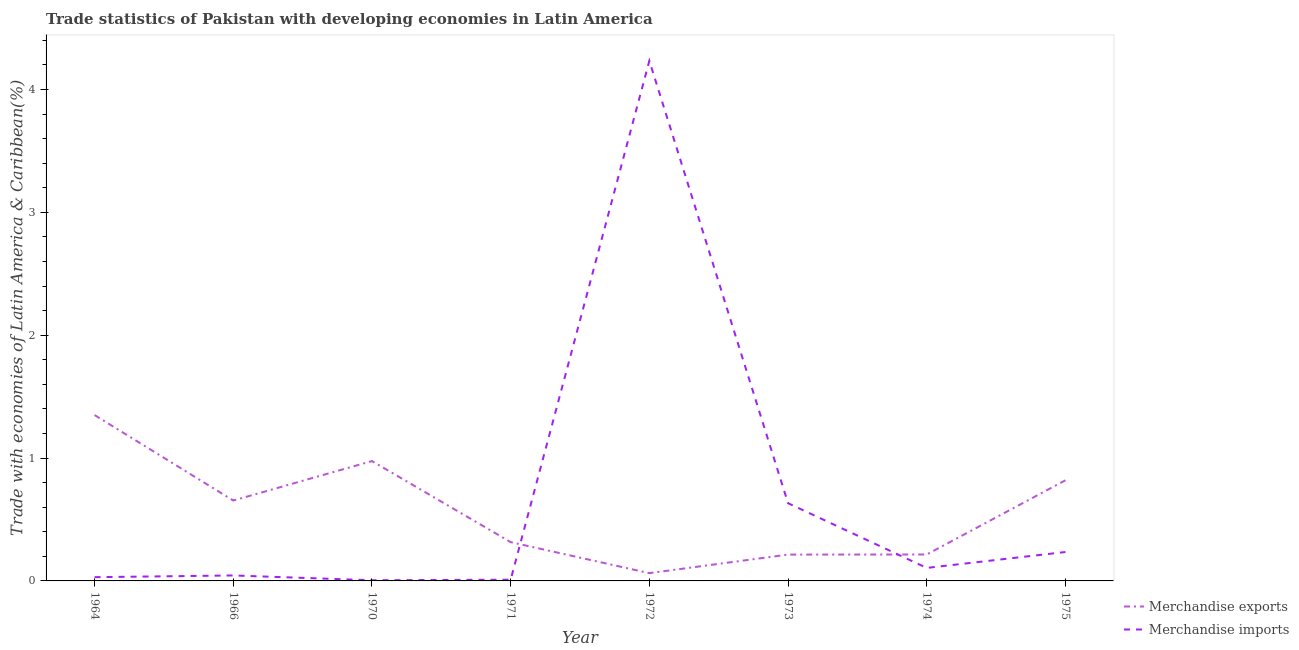What is the merchandise exports in 1972?
Provide a short and direct response. 0.06. Across all years, what is the maximum merchandise imports?
Provide a succinct answer. 4.23. Across all years, what is the minimum merchandise exports?
Keep it short and to the point. 0.06. In which year was the merchandise exports maximum?
Offer a very short reply. 1964. What is the total merchandise imports in the graph?
Your response must be concise. 5.3. What is the difference between the merchandise imports in 1972 and that in 1974?
Provide a short and direct response. 4.13. What is the difference between the merchandise exports in 1974 and the merchandise imports in 1971?
Give a very brief answer. 0.21. What is the average merchandise imports per year?
Provide a succinct answer. 0.66. In the year 1966, what is the difference between the merchandise imports and merchandise exports?
Make the answer very short. -0.61. In how many years, is the merchandise imports greater than 3 %?
Provide a short and direct response. 1. What is the ratio of the merchandise imports in 1973 to that in 1974?
Provide a short and direct response. 5.98. Is the merchandise exports in 1964 less than that in 1970?
Provide a short and direct response. No. What is the difference between the highest and the second highest merchandise exports?
Make the answer very short. 0.37. What is the difference between the highest and the lowest merchandise exports?
Ensure brevity in your answer.  1.29. In how many years, is the merchandise exports greater than the average merchandise exports taken over all years?
Your response must be concise. 4. Is the sum of the merchandise exports in 1964 and 1973 greater than the maximum merchandise imports across all years?
Your answer should be very brief. No. How many lines are there?
Ensure brevity in your answer.  2. What is the difference between two consecutive major ticks on the Y-axis?
Provide a short and direct response. 1. Does the graph contain grids?
Your answer should be very brief. No. How many legend labels are there?
Offer a very short reply. 2. How are the legend labels stacked?
Offer a very short reply. Vertical. What is the title of the graph?
Give a very brief answer. Trade statistics of Pakistan with developing economies in Latin America. Does "Male entrants" appear as one of the legend labels in the graph?
Provide a succinct answer. No. What is the label or title of the X-axis?
Offer a terse response. Year. What is the label or title of the Y-axis?
Provide a short and direct response. Trade with economies of Latin America & Caribbean(%). What is the Trade with economies of Latin America & Caribbean(%) of Merchandise exports in 1964?
Keep it short and to the point. 1.35. What is the Trade with economies of Latin America & Caribbean(%) in Merchandise imports in 1964?
Ensure brevity in your answer.  0.03. What is the Trade with economies of Latin America & Caribbean(%) in Merchandise exports in 1966?
Make the answer very short. 0.65. What is the Trade with economies of Latin America & Caribbean(%) of Merchandise imports in 1966?
Offer a very short reply. 0.04. What is the Trade with economies of Latin America & Caribbean(%) of Merchandise exports in 1970?
Offer a terse response. 0.98. What is the Trade with economies of Latin America & Caribbean(%) in Merchandise imports in 1970?
Provide a short and direct response. 0.01. What is the Trade with economies of Latin America & Caribbean(%) in Merchandise exports in 1971?
Offer a very short reply. 0.32. What is the Trade with economies of Latin America & Caribbean(%) in Merchandise imports in 1971?
Give a very brief answer. 0.01. What is the Trade with economies of Latin America & Caribbean(%) in Merchandise exports in 1972?
Ensure brevity in your answer.  0.06. What is the Trade with economies of Latin America & Caribbean(%) of Merchandise imports in 1972?
Offer a very short reply. 4.23. What is the Trade with economies of Latin America & Caribbean(%) in Merchandise exports in 1973?
Offer a very short reply. 0.21. What is the Trade with economies of Latin America & Caribbean(%) of Merchandise imports in 1973?
Your answer should be very brief. 0.63. What is the Trade with economies of Latin America & Caribbean(%) of Merchandise exports in 1974?
Provide a succinct answer. 0.22. What is the Trade with economies of Latin America & Caribbean(%) of Merchandise imports in 1974?
Your answer should be very brief. 0.11. What is the Trade with economies of Latin America & Caribbean(%) of Merchandise exports in 1975?
Your response must be concise. 0.82. What is the Trade with economies of Latin America & Caribbean(%) in Merchandise imports in 1975?
Your answer should be very brief. 0.24. Across all years, what is the maximum Trade with economies of Latin America & Caribbean(%) of Merchandise exports?
Your answer should be very brief. 1.35. Across all years, what is the maximum Trade with economies of Latin America & Caribbean(%) in Merchandise imports?
Provide a succinct answer. 4.23. Across all years, what is the minimum Trade with economies of Latin America & Caribbean(%) in Merchandise exports?
Keep it short and to the point. 0.06. Across all years, what is the minimum Trade with economies of Latin America & Caribbean(%) of Merchandise imports?
Ensure brevity in your answer.  0.01. What is the total Trade with economies of Latin America & Caribbean(%) in Merchandise exports in the graph?
Make the answer very short. 4.61. What is the total Trade with economies of Latin America & Caribbean(%) in Merchandise imports in the graph?
Keep it short and to the point. 5.3. What is the difference between the Trade with economies of Latin America & Caribbean(%) in Merchandise exports in 1964 and that in 1966?
Your answer should be compact. 0.7. What is the difference between the Trade with economies of Latin America & Caribbean(%) of Merchandise imports in 1964 and that in 1966?
Offer a terse response. -0.01. What is the difference between the Trade with economies of Latin America & Caribbean(%) in Merchandise exports in 1964 and that in 1970?
Your response must be concise. 0.37. What is the difference between the Trade with economies of Latin America & Caribbean(%) in Merchandise imports in 1964 and that in 1970?
Make the answer very short. 0.03. What is the difference between the Trade with economies of Latin America & Caribbean(%) in Merchandise exports in 1964 and that in 1971?
Your answer should be compact. 1.03. What is the difference between the Trade with economies of Latin America & Caribbean(%) of Merchandise imports in 1964 and that in 1971?
Provide a short and direct response. 0.02. What is the difference between the Trade with economies of Latin America & Caribbean(%) of Merchandise exports in 1964 and that in 1972?
Your answer should be very brief. 1.29. What is the difference between the Trade with economies of Latin America & Caribbean(%) of Merchandise imports in 1964 and that in 1972?
Make the answer very short. -4.2. What is the difference between the Trade with economies of Latin America & Caribbean(%) of Merchandise exports in 1964 and that in 1973?
Give a very brief answer. 1.14. What is the difference between the Trade with economies of Latin America & Caribbean(%) in Merchandise imports in 1964 and that in 1973?
Offer a very short reply. -0.6. What is the difference between the Trade with economies of Latin America & Caribbean(%) in Merchandise exports in 1964 and that in 1974?
Your answer should be very brief. 1.13. What is the difference between the Trade with economies of Latin America & Caribbean(%) of Merchandise imports in 1964 and that in 1974?
Ensure brevity in your answer.  -0.08. What is the difference between the Trade with economies of Latin America & Caribbean(%) in Merchandise exports in 1964 and that in 1975?
Your answer should be very brief. 0.53. What is the difference between the Trade with economies of Latin America & Caribbean(%) of Merchandise imports in 1964 and that in 1975?
Your answer should be compact. -0.2. What is the difference between the Trade with economies of Latin America & Caribbean(%) of Merchandise exports in 1966 and that in 1970?
Offer a terse response. -0.32. What is the difference between the Trade with economies of Latin America & Caribbean(%) in Merchandise imports in 1966 and that in 1970?
Offer a terse response. 0.04. What is the difference between the Trade with economies of Latin America & Caribbean(%) of Merchandise exports in 1966 and that in 1971?
Your response must be concise. 0.34. What is the difference between the Trade with economies of Latin America & Caribbean(%) of Merchandise imports in 1966 and that in 1971?
Give a very brief answer. 0.03. What is the difference between the Trade with economies of Latin America & Caribbean(%) of Merchandise exports in 1966 and that in 1972?
Your response must be concise. 0.59. What is the difference between the Trade with economies of Latin America & Caribbean(%) of Merchandise imports in 1966 and that in 1972?
Your answer should be compact. -4.19. What is the difference between the Trade with economies of Latin America & Caribbean(%) in Merchandise exports in 1966 and that in 1973?
Your response must be concise. 0.44. What is the difference between the Trade with economies of Latin America & Caribbean(%) in Merchandise imports in 1966 and that in 1973?
Your response must be concise. -0.59. What is the difference between the Trade with economies of Latin America & Caribbean(%) in Merchandise exports in 1966 and that in 1974?
Your response must be concise. 0.44. What is the difference between the Trade with economies of Latin America & Caribbean(%) in Merchandise imports in 1966 and that in 1974?
Your answer should be very brief. -0.06. What is the difference between the Trade with economies of Latin America & Caribbean(%) in Merchandise exports in 1966 and that in 1975?
Your response must be concise. -0.16. What is the difference between the Trade with economies of Latin America & Caribbean(%) of Merchandise imports in 1966 and that in 1975?
Your answer should be very brief. -0.19. What is the difference between the Trade with economies of Latin America & Caribbean(%) of Merchandise exports in 1970 and that in 1971?
Offer a terse response. 0.66. What is the difference between the Trade with economies of Latin America & Caribbean(%) of Merchandise imports in 1970 and that in 1971?
Offer a terse response. -0. What is the difference between the Trade with economies of Latin America & Caribbean(%) of Merchandise exports in 1970 and that in 1972?
Your response must be concise. 0.91. What is the difference between the Trade with economies of Latin America & Caribbean(%) of Merchandise imports in 1970 and that in 1972?
Provide a succinct answer. -4.23. What is the difference between the Trade with economies of Latin America & Caribbean(%) of Merchandise exports in 1970 and that in 1973?
Offer a terse response. 0.76. What is the difference between the Trade with economies of Latin America & Caribbean(%) in Merchandise imports in 1970 and that in 1973?
Offer a terse response. -0.63. What is the difference between the Trade with economies of Latin America & Caribbean(%) in Merchandise exports in 1970 and that in 1974?
Provide a short and direct response. 0.76. What is the difference between the Trade with economies of Latin America & Caribbean(%) in Merchandise imports in 1970 and that in 1974?
Your response must be concise. -0.1. What is the difference between the Trade with economies of Latin America & Caribbean(%) of Merchandise exports in 1970 and that in 1975?
Make the answer very short. 0.16. What is the difference between the Trade with economies of Latin America & Caribbean(%) of Merchandise imports in 1970 and that in 1975?
Your answer should be very brief. -0.23. What is the difference between the Trade with economies of Latin America & Caribbean(%) in Merchandise exports in 1971 and that in 1972?
Offer a terse response. 0.25. What is the difference between the Trade with economies of Latin America & Caribbean(%) of Merchandise imports in 1971 and that in 1972?
Give a very brief answer. -4.22. What is the difference between the Trade with economies of Latin America & Caribbean(%) of Merchandise exports in 1971 and that in 1973?
Your answer should be compact. 0.1. What is the difference between the Trade with economies of Latin America & Caribbean(%) in Merchandise imports in 1971 and that in 1973?
Your answer should be very brief. -0.62. What is the difference between the Trade with economies of Latin America & Caribbean(%) in Merchandise exports in 1971 and that in 1974?
Keep it short and to the point. 0.1. What is the difference between the Trade with economies of Latin America & Caribbean(%) in Merchandise imports in 1971 and that in 1974?
Provide a succinct answer. -0.1. What is the difference between the Trade with economies of Latin America & Caribbean(%) of Merchandise exports in 1971 and that in 1975?
Your response must be concise. -0.5. What is the difference between the Trade with economies of Latin America & Caribbean(%) in Merchandise imports in 1971 and that in 1975?
Your answer should be very brief. -0.23. What is the difference between the Trade with economies of Latin America & Caribbean(%) of Merchandise exports in 1972 and that in 1973?
Your answer should be very brief. -0.15. What is the difference between the Trade with economies of Latin America & Caribbean(%) of Merchandise imports in 1972 and that in 1973?
Make the answer very short. 3.6. What is the difference between the Trade with economies of Latin America & Caribbean(%) in Merchandise exports in 1972 and that in 1974?
Offer a terse response. -0.15. What is the difference between the Trade with economies of Latin America & Caribbean(%) in Merchandise imports in 1972 and that in 1974?
Provide a short and direct response. 4.13. What is the difference between the Trade with economies of Latin America & Caribbean(%) in Merchandise exports in 1972 and that in 1975?
Keep it short and to the point. -0.76. What is the difference between the Trade with economies of Latin America & Caribbean(%) of Merchandise imports in 1972 and that in 1975?
Your answer should be compact. 4. What is the difference between the Trade with economies of Latin America & Caribbean(%) in Merchandise exports in 1973 and that in 1974?
Give a very brief answer. -0. What is the difference between the Trade with economies of Latin America & Caribbean(%) of Merchandise imports in 1973 and that in 1974?
Your response must be concise. 0.53. What is the difference between the Trade with economies of Latin America & Caribbean(%) of Merchandise exports in 1973 and that in 1975?
Keep it short and to the point. -0.6. What is the difference between the Trade with economies of Latin America & Caribbean(%) of Merchandise imports in 1973 and that in 1975?
Provide a short and direct response. 0.4. What is the difference between the Trade with economies of Latin America & Caribbean(%) of Merchandise exports in 1974 and that in 1975?
Provide a succinct answer. -0.6. What is the difference between the Trade with economies of Latin America & Caribbean(%) of Merchandise imports in 1974 and that in 1975?
Your answer should be very brief. -0.13. What is the difference between the Trade with economies of Latin America & Caribbean(%) in Merchandise exports in 1964 and the Trade with economies of Latin America & Caribbean(%) in Merchandise imports in 1966?
Your response must be concise. 1.31. What is the difference between the Trade with economies of Latin America & Caribbean(%) in Merchandise exports in 1964 and the Trade with economies of Latin America & Caribbean(%) in Merchandise imports in 1970?
Give a very brief answer. 1.34. What is the difference between the Trade with economies of Latin America & Caribbean(%) in Merchandise exports in 1964 and the Trade with economies of Latin America & Caribbean(%) in Merchandise imports in 1971?
Offer a terse response. 1.34. What is the difference between the Trade with economies of Latin America & Caribbean(%) in Merchandise exports in 1964 and the Trade with economies of Latin America & Caribbean(%) in Merchandise imports in 1972?
Provide a succinct answer. -2.88. What is the difference between the Trade with economies of Latin America & Caribbean(%) in Merchandise exports in 1964 and the Trade with economies of Latin America & Caribbean(%) in Merchandise imports in 1973?
Make the answer very short. 0.72. What is the difference between the Trade with economies of Latin America & Caribbean(%) of Merchandise exports in 1964 and the Trade with economies of Latin America & Caribbean(%) of Merchandise imports in 1974?
Your response must be concise. 1.24. What is the difference between the Trade with economies of Latin America & Caribbean(%) of Merchandise exports in 1964 and the Trade with economies of Latin America & Caribbean(%) of Merchandise imports in 1975?
Offer a terse response. 1.11. What is the difference between the Trade with economies of Latin America & Caribbean(%) of Merchandise exports in 1966 and the Trade with economies of Latin America & Caribbean(%) of Merchandise imports in 1970?
Your response must be concise. 0.65. What is the difference between the Trade with economies of Latin America & Caribbean(%) of Merchandise exports in 1966 and the Trade with economies of Latin America & Caribbean(%) of Merchandise imports in 1971?
Your answer should be compact. 0.64. What is the difference between the Trade with economies of Latin America & Caribbean(%) in Merchandise exports in 1966 and the Trade with economies of Latin America & Caribbean(%) in Merchandise imports in 1972?
Make the answer very short. -3.58. What is the difference between the Trade with economies of Latin America & Caribbean(%) of Merchandise exports in 1966 and the Trade with economies of Latin America & Caribbean(%) of Merchandise imports in 1973?
Your response must be concise. 0.02. What is the difference between the Trade with economies of Latin America & Caribbean(%) of Merchandise exports in 1966 and the Trade with economies of Latin America & Caribbean(%) of Merchandise imports in 1974?
Ensure brevity in your answer.  0.55. What is the difference between the Trade with economies of Latin America & Caribbean(%) of Merchandise exports in 1966 and the Trade with economies of Latin America & Caribbean(%) of Merchandise imports in 1975?
Offer a terse response. 0.42. What is the difference between the Trade with economies of Latin America & Caribbean(%) of Merchandise exports in 1970 and the Trade with economies of Latin America & Caribbean(%) of Merchandise imports in 1971?
Ensure brevity in your answer.  0.97. What is the difference between the Trade with economies of Latin America & Caribbean(%) of Merchandise exports in 1970 and the Trade with economies of Latin America & Caribbean(%) of Merchandise imports in 1972?
Your answer should be compact. -3.26. What is the difference between the Trade with economies of Latin America & Caribbean(%) in Merchandise exports in 1970 and the Trade with economies of Latin America & Caribbean(%) in Merchandise imports in 1973?
Ensure brevity in your answer.  0.34. What is the difference between the Trade with economies of Latin America & Caribbean(%) in Merchandise exports in 1970 and the Trade with economies of Latin America & Caribbean(%) in Merchandise imports in 1974?
Offer a very short reply. 0.87. What is the difference between the Trade with economies of Latin America & Caribbean(%) in Merchandise exports in 1970 and the Trade with economies of Latin America & Caribbean(%) in Merchandise imports in 1975?
Make the answer very short. 0.74. What is the difference between the Trade with economies of Latin America & Caribbean(%) of Merchandise exports in 1971 and the Trade with economies of Latin America & Caribbean(%) of Merchandise imports in 1972?
Your response must be concise. -3.92. What is the difference between the Trade with economies of Latin America & Caribbean(%) in Merchandise exports in 1971 and the Trade with economies of Latin America & Caribbean(%) in Merchandise imports in 1973?
Offer a terse response. -0.32. What is the difference between the Trade with economies of Latin America & Caribbean(%) of Merchandise exports in 1971 and the Trade with economies of Latin America & Caribbean(%) of Merchandise imports in 1974?
Provide a succinct answer. 0.21. What is the difference between the Trade with economies of Latin America & Caribbean(%) in Merchandise exports in 1971 and the Trade with economies of Latin America & Caribbean(%) in Merchandise imports in 1975?
Your answer should be compact. 0.08. What is the difference between the Trade with economies of Latin America & Caribbean(%) in Merchandise exports in 1972 and the Trade with economies of Latin America & Caribbean(%) in Merchandise imports in 1973?
Your answer should be compact. -0.57. What is the difference between the Trade with economies of Latin America & Caribbean(%) of Merchandise exports in 1972 and the Trade with economies of Latin America & Caribbean(%) of Merchandise imports in 1974?
Ensure brevity in your answer.  -0.04. What is the difference between the Trade with economies of Latin America & Caribbean(%) of Merchandise exports in 1972 and the Trade with economies of Latin America & Caribbean(%) of Merchandise imports in 1975?
Make the answer very short. -0.17. What is the difference between the Trade with economies of Latin America & Caribbean(%) of Merchandise exports in 1973 and the Trade with economies of Latin America & Caribbean(%) of Merchandise imports in 1974?
Keep it short and to the point. 0.11. What is the difference between the Trade with economies of Latin America & Caribbean(%) in Merchandise exports in 1973 and the Trade with economies of Latin America & Caribbean(%) in Merchandise imports in 1975?
Make the answer very short. -0.02. What is the difference between the Trade with economies of Latin America & Caribbean(%) of Merchandise exports in 1974 and the Trade with economies of Latin America & Caribbean(%) of Merchandise imports in 1975?
Keep it short and to the point. -0.02. What is the average Trade with economies of Latin America & Caribbean(%) in Merchandise exports per year?
Provide a short and direct response. 0.58. What is the average Trade with economies of Latin America & Caribbean(%) in Merchandise imports per year?
Give a very brief answer. 0.66. In the year 1964, what is the difference between the Trade with economies of Latin America & Caribbean(%) in Merchandise exports and Trade with economies of Latin America & Caribbean(%) in Merchandise imports?
Ensure brevity in your answer.  1.32. In the year 1966, what is the difference between the Trade with economies of Latin America & Caribbean(%) of Merchandise exports and Trade with economies of Latin America & Caribbean(%) of Merchandise imports?
Your answer should be very brief. 0.61. In the year 1970, what is the difference between the Trade with economies of Latin America & Caribbean(%) in Merchandise exports and Trade with economies of Latin America & Caribbean(%) in Merchandise imports?
Provide a succinct answer. 0.97. In the year 1971, what is the difference between the Trade with economies of Latin America & Caribbean(%) of Merchandise exports and Trade with economies of Latin America & Caribbean(%) of Merchandise imports?
Provide a succinct answer. 0.31. In the year 1972, what is the difference between the Trade with economies of Latin America & Caribbean(%) of Merchandise exports and Trade with economies of Latin America & Caribbean(%) of Merchandise imports?
Keep it short and to the point. -4.17. In the year 1973, what is the difference between the Trade with economies of Latin America & Caribbean(%) in Merchandise exports and Trade with economies of Latin America & Caribbean(%) in Merchandise imports?
Offer a very short reply. -0.42. In the year 1974, what is the difference between the Trade with economies of Latin America & Caribbean(%) in Merchandise exports and Trade with economies of Latin America & Caribbean(%) in Merchandise imports?
Make the answer very short. 0.11. In the year 1975, what is the difference between the Trade with economies of Latin America & Caribbean(%) of Merchandise exports and Trade with economies of Latin America & Caribbean(%) of Merchandise imports?
Offer a very short reply. 0.58. What is the ratio of the Trade with economies of Latin America & Caribbean(%) of Merchandise exports in 1964 to that in 1966?
Offer a very short reply. 2.06. What is the ratio of the Trade with economies of Latin America & Caribbean(%) of Merchandise imports in 1964 to that in 1966?
Keep it short and to the point. 0.69. What is the ratio of the Trade with economies of Latin America & Caribbean(%) in Merchandise exports in 1964 to that in 1970?
Provide a succinct answer. 1.38. What is the ratio of the Trade with economies of Latin America & Caribbean(%) in Merchandise imports in 1964 to that in 1970?
Offer a terse response. 5.6. What is the ratio of the Trade with economies of Latin America & Caribbean(%) of Merchandise exports in 1964 to that in 1971?
Provide a succinct answer. 4.28. What is the ratio of the Trade with economies of Latin America & Caribbean(%) of Merchandise imports in 1964 to that in 1971?
Give a very brief answer. 3.1. What is the ratio of the Trade with economies of Latin America & Caribbean(%) in Merchandise exports in 1964 to that in 1972?
Provide a short and direct response. 21.32. What is the ratio of the Trade with economies of Latin America & Caribbean(%) in Merchandise imports in 1964 to that in 1972?
Ensure brevity in your answer.  0.01. What is the ratio of the Trade with economies of Latin America & Caribbean(%) of Merchandise exports in 1964 to that in 1973?
Give a very brief answer. 6.3. What is the ratio of the Trade with economies of Latin America & Caribbean(%) in Merchandise imports in 1964 to that in 1973?
Provide a succinct answer. 0.05. What is the ratio of the Trade with economies of Latin America & Caribbean(%) in Merchandise exports in 1964 to that in 1974?
Your response must be concise. 6.28. What is the ratio of the Trade with economies of Latin America & Caribbean(%) of Merchandise imports in 1964 to that in 1974?
Make the answer very short. 0.29. What is the ratio of the Trade with economies of Latin America & Caribbean(%) of Merchandise exports in 1964 to that in 1975?
Your response must be concise. 1.65. What is the ratio of the Trade with economies of Latin America & Caribbean(%) in Merchandise imports in 1964 to that in 1975?
Your answer should be compact. 0.13. What is the ratio of the Trade with economies of Latin America & Caribbean(%) in Merchandise exports in 1966 to that in 1970?
Provide a succinct answer. 0.67. What is the ratio of the Trade with economies of Latin America & Caribbean(%) of Merchandise imports in 1966 to that in 1970?
Your response must be concise. 8.17. What is the ratio of the Trade with economies of Latin America & Caribbean(%) of Merchandise exports in 1966 to that in 1971?
Keep it short and to the point. 2.07. What is the ratio of the Trade with economies of Latin America & Caribbean(%) of Merchandise imports in 1966 to that in 1971?
Make the answer very short. 4.53. What is the ratio of the Trade with economies of Latin America & Caribbean(%) in Merchandise exports in 1966 to that in 1972?
Provide a short and direct response. 10.34. What is the ratio of the Trade with economies of Latin America & Caribbean(%) in Merchandise imports in 1966 to that in 1972?
Provide a succinct answer. 0.01. What is the ratio of the Trade with economies of Latin America & Caribbean(%) in Merchandise exports in 1966 to that in 1973?
Offer a very short reply. 3.05. What is the ratio of the Trade with economies of Latin America & Caribbean(%) of Merchandise imports in 1966 to that in 1973?
Your answer should be very brief. 0.07. What is the ratio of the Trade with economies of Latin America & Caribbean(%) of Merchandise exports in 1966 to that in 1974?
Make the answer very short. 3.04. What is the ratio of the Trade with economies of Latin America & Caribbean(%) in Merchandise imports in 1966 to that in 1974?
Your answer should be compact. 0.42. What is the ratio of the Trade with economies of Latin America & Caribbean(%) of Merchandise exports in 1966 to that in 1975?
Give a very brief answer. 0.8. What is the ratio of the Trade with economies of Latin America & Caribbean(%) of Merchandise imports in 1966 to that in 1975?
Your answer should be very brief. 0.19. What is the ratio of the Trade with economies of Latin America & Caribbean(%) in Merchandise exports in 1970 to that in 1971?
Offer a terse response. 3.09. What is the ratio of the Trade with economies of Latin America & Caribbean(%) of Merchandise imports in 1970 to that in 1971?
Keep it short and to the point. 0.55. What is the ratio of the Trade with economies of Latin America & Caribbean(%) in Merchandise exports in 1970 to that in 1972?
Offer a terse response. 15.41. What is the ratio of the Trade with economies of Latin America & Caribbean(%) of Merchandise imports in 1970 to that in 1972?
Provide a succinct answer. 0. What is the ratio of the Trade with economies of Latin America & Caribbean(%) of Merchandise exports in 1970 to that in 1973?
Offer a very short reply. 4.55. What is the ratio of the Trade with economies of Latin America & Caribbean(%) in Merchandise imports in 1970 to that in 1973?
Keep it short and to the point. 0.01. What is the ratio of the Trade with economies of Latin America & Caribbean(%) of Merchandise exports in 1970 to that in 1974?
Your response must be concise. 4.53. What is the ratio of the Trade with economies of Latin America & Caribbean(%) in Merchandise imports in 1970 to that in 1974?
Provide a succinct answer. 0.05. What is the ratio of the Trade with economies of Latin America & Caribbean(%) in Merchandise exports in 1970 to that in 1975?
Make the answer very short. 1.19. What is the ratio of the Trade with economies of Latin America & Caribbean(%) in Merchandise imports in 1970 to that in 1975?
Provide a short and direct response. 0.02. What is the ratio of the Trade with economies of Latin America & Caribbean(%) of Merchandise exports in 1971 to that in 1972?
Offer a very short reply. 4.99. What is the ratio of the Trade with economies of Latin America & Caribbean(%) of Merchandise imports in 1971 to that in 1972?
Keep it short and to the point. 0. What is the ratio of the Trade with economies of Latin America & Caribbean(%) of Merchandise exports in 1971 to that in 1973?
Provide a succinct answer. 1.47. What is the ratio of the Trade with economies of Latin America & Caribbean(%) in Merchandise imports in 1971 to that in 1973?
Offer a terse response. 0.02. What is the ratio of the Trade with economies of Latin America & Caribbean(%) of Merchandise exports in 1971 to that in 1974?
Ensure brevity in your answer.  1.47. What is the ratio of the Trade with economies of Latin America & Caribbean(%) of Merchandise imports in 1971 to that in 1974?
Ensure brevity in your answer.  0.09. What is the ratio of the Trade with economies of Latin America & Caribbean(%) in Merchandise exports in 1971 to that in 1975?
Ensure brevity in your answer.  0.39. What is the ratio of the Trade with economies of Latin America & Caribbean(%) of Merchandise imports in 1971 to that in 1975?
Make the answer very short. 0.04. What is the ratio of the Trade with economies of Latin America & Caribbean(%) of Merchandise exports in 1972 to that in 1973?
Give a very brief answer. 0.3. What is the ratio of the Trade with economies of Latin America & Caribbean(%) in Merchandise imports in 1972 to that in 1973?
Your answer should be compact. 6.69. What is the ratio of the Trade with economies of Latin America & Caribbean(%) of Merchandise exports in 1972 to that in 1974?
Offer a terse response. 0.29. What is the ratio of the Trade with economies of Latin America & Caribbean(%) of Merchandise imports in 1972 to that in 1974?
Offer a very short reply. 40.03. What is the ratio of the Trade with economies of Latin America & Caribbean(%) of Merchandise exports in 1972 to that in 1975?
Offer a terse response. 0.08. What is the ratio of the Trade with economies of Latin America & Caribbean(%) of Merchandise imports in 1972 to that in 1975?
Offer a very short reply. 17.99. What is the ratio of the Trade with economies of Latin America & Caribbean(%) in Merchandise exports in 1973 to that in 1974?
Provide a succinct answer. 1. What is the ratio of the Trade with economies of Latin America & Caribbean(%) in Merchandise imports in 1973 to that in 1974?
Offer a very short reply. 5.98. What is the ratio of the Trade with economies of Latin America & Caribbean(%) in Merchandise exports in 1973 to that in 1975?
Provide a short and direct response. 0.26. What is the ratio of the Trade with economies of Latin America & Caribbean(%) of Merchandise imports in 1973 to that in 1975?
Make the answer very short. 2.69. What is the ratio of the Trade with economies of Latin America & Caribbean(%) of Merchandise exports in 1974 to that in 1975?
Your answer should be compact. 0.26. What is the ratio of the Trade with economies of Latin America & Caribbean(%) of Merchandise imports in 1974 to that in 1975?
Offer a terse response. 0.45. What is the difference between the highest and the second highest Trade with economies of Latin America & Caribbean(%) of Merchandise exports?
Keep it short and to the point. 0.37. What is the difference between the highest and the second highest Trade with economies of Latin America & Caribbean(%) of Merchandise imports?
Ensure brevity in your answer.  3.6. What is the difference between the highest and the lowest Trade with economies of Latin America & Caribbean(%) of Merchandise exports?
Keep it short and to the point. 1.29. What is the difference between the highest and the lowest Trade with economies of Latin America & Caribbean(%) of Merchandise imports?
Ensure brevity in your answer.  4.23. 